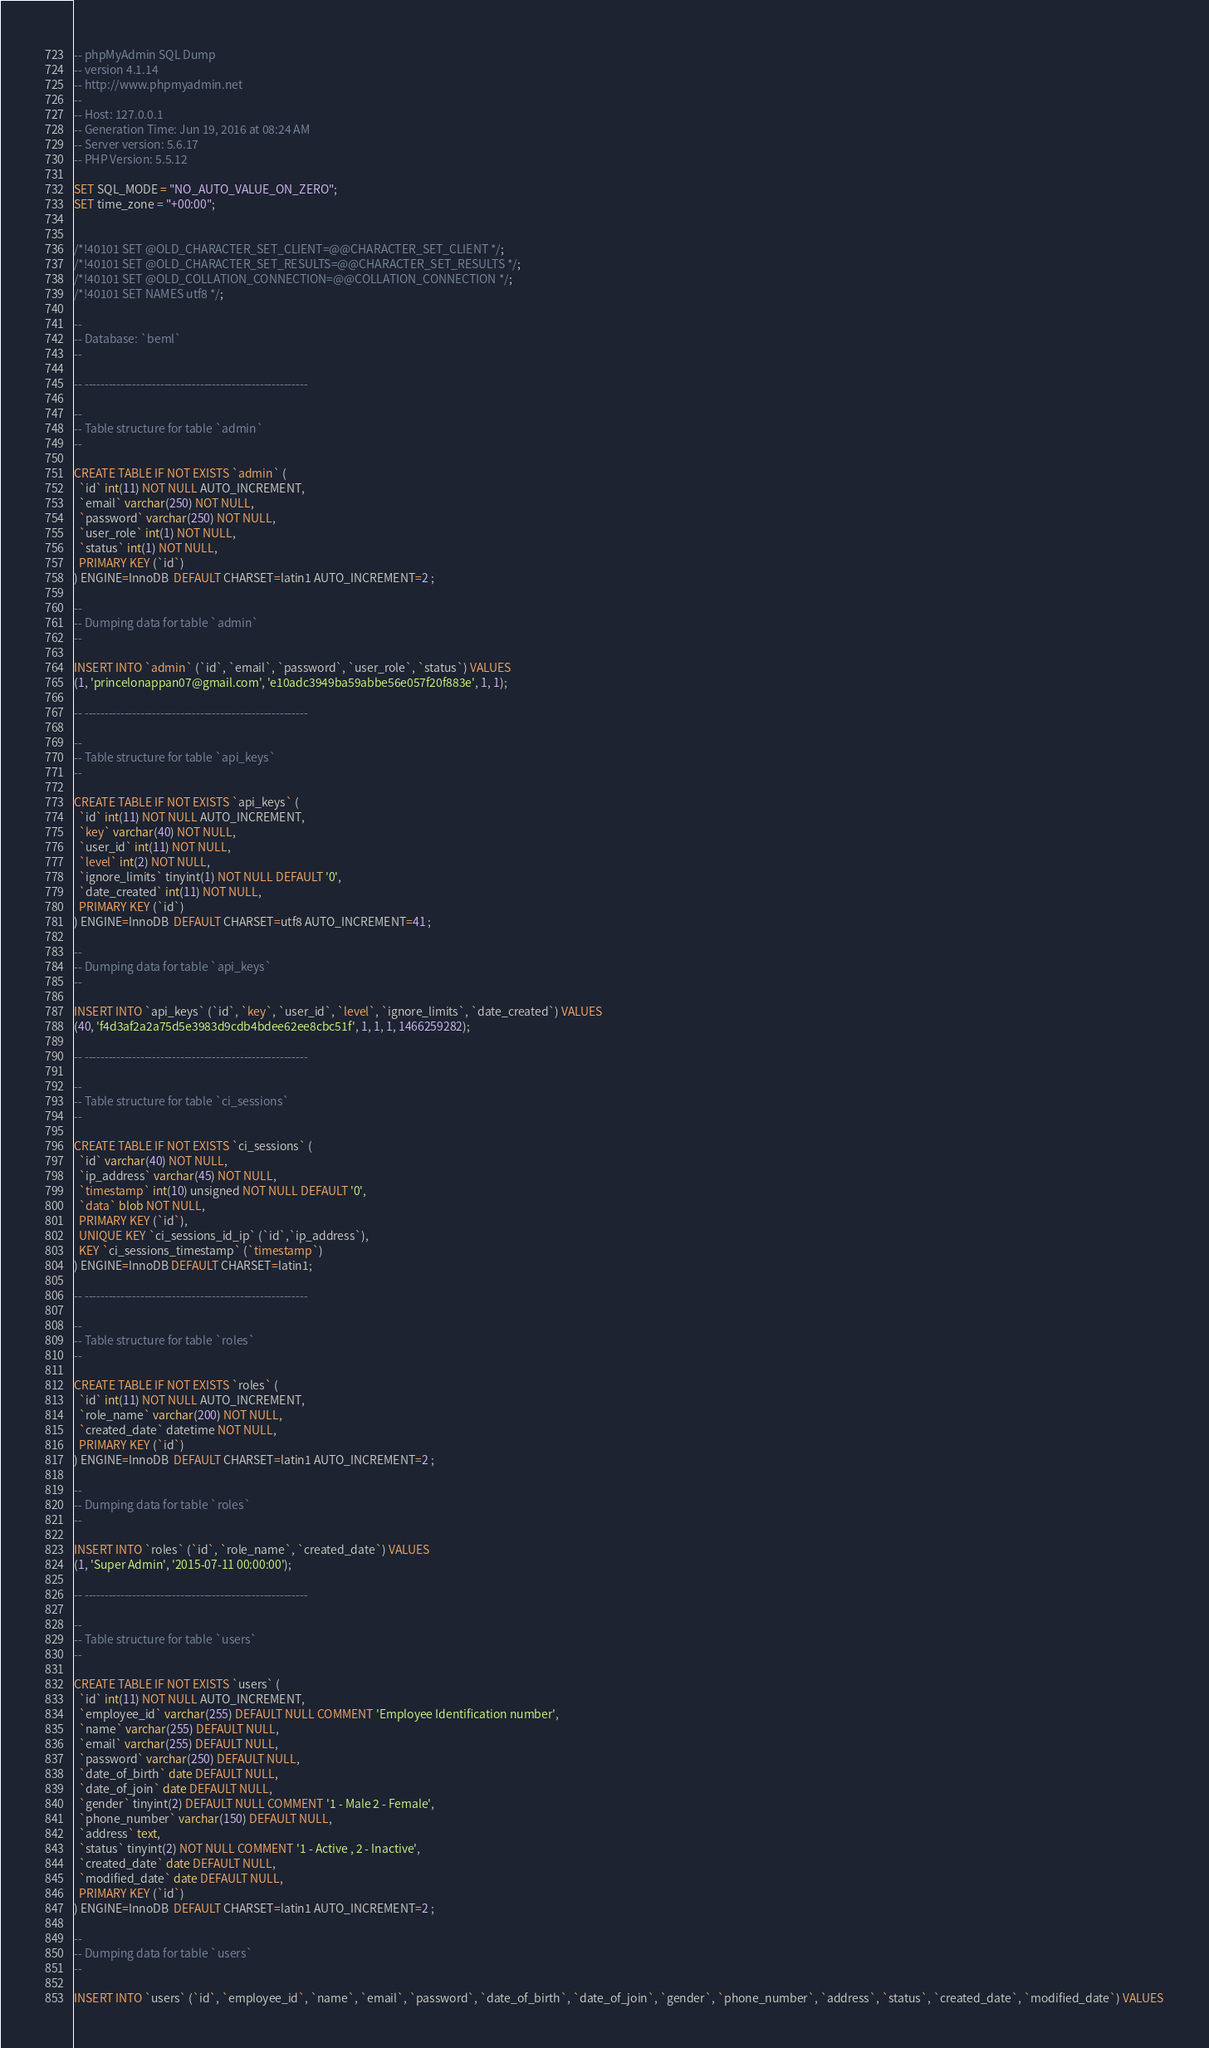Convert code to text. <code><loc_0><loc_0><loc_500><loc_500><_SQL_>-- phpMyAdmin SQL Dump
-- version 4.1.14
-- http://www.phpmyadmin.net
--
-- Host: 127.0.0.1
-- Generation Time: Jun 19, 2016 at 08:24 AM
-- Server version: 5.6.17
-- PHP Version: 5.5.12

SET SQL_MODE = "NO_AUTO_VALUE_ON_ZERO";
SET time_zone = "+00:00";


/*!40101 SET @OLD_CHARACTER_SET_CLIENT=@@CHARACTER_SET_CLIENT */;
/*!40101 SET @OLD_CHARACTER_SET_RESULTS=@@CHARACTER_SET_RESULTS */;
/*!40101 SET @OLD_COLLATION_CONNECTION=@@COLLATION_CONNECTION */;
/*!40101 SET NAMES utf8 */;

--
-- Database: `beml`
--

-- --------------------------------------------------------

--
-- Table structure for table `admin`
--

CREATE TABLE IF NOT EXISTS `admin` (
  `id` int(11) NOT NULL AUTO_INCREMENT,
  `email` varchar(250) NOT NULL,
  `password` varchar(250) NOT NULL,
  `user_role` int(1) NOT NULL,
  `status` int(1) NOT NULL,
  PRIMARY KEY (`id`)
) ENGINE=InnoDB  DEFAULT CHARSET=latin1 AUTO_INCREMENT=2 ;

--
-- Dumping data for table `admin`
--

INSERT INTO `admin` (`id`, `email`, `password`, `user_role`, `status`) VALUES
(1, 'princelonappan07@gmail.com', 'e10adc3949ba59abbe56e057f20f883e', 1, 1);

-- --------------------------------------------------------

--
-- Table structure for table `api_keys`
--

CREATE TABLE IF NOT EXISTS `api_keys` (
  `id` int(11) NOT NULL AUTO_INCREMENT,
  `key` varchar(40) NOT NULL,
  `user_id` int(11) NOT NULL,
  `level` int(2) NOT NULL,
  `ignore_limits` tinyint(1) NOT NULL DEFAULT '0',
  `date_created` int(11) NOT NULL,
  PRIMARY KEY (`id`)
) ENGINE=InnoDB  DEFAULT CHARSET=utf8 AUTO_INCREMENT=41 ;

--
-- Dumping data for table `api_keys`
--

INSERT INTO `api_keys` (`id`, `key`, `user_id`, `level`, `ignore_limits`, `date_created`) VALUES
(40, 'f4d3af2a2a75d5e3983d9cdb4bdee62ee8cbc51f', 1, 1, 1, 1466259282);

-- --------------------------------------------------------

--
-- Table structure for table `ci_sessions`
--

CREATE TABLE IF NOT EXISTS `ci_sessions` (
  `id` varchar(40) NOT NULL,
  `ip_address` varchar(45) NOT NULL,
  `timestamp` int(10) unsigned NOT NULL DEFAULT '0',
  `data` blob NOT NULL,
  PRIMARY KEY (`id`),
  UNIQUE KEY `ci_sessions_id_ip` (`id`,`ip_address`),
  KEY `ci_sessions_timestamp` (`timestamp`)
) ENGINE=InnoDB DEFAULT CHARSET=latin1;

-- --------------------------------------------------------

--
-- Table structure for table `roles`
--

CREATE TABLE IF NOT EXISTS `roles` (
  `id` int(11) NOT NULL AUTO_INCREMENT,
  `role_name` varchar(200) NOT NULL,
  `created_date` datetime NOT NULL,
  PRIMARY KEY (`id`)
) ENGINE=InnoDB  DEFAULT CHARSET=latin1 AUTO_INCREMENT=2 ;

--
-- Dumping data for table `roles`
--

INSERT INTO `roles` (`id`, `role_name`, `created_date`) VALUES
(1, 'Super Admin', '2015-07-11 00:00:00');

-- --------------------------------------------------------

--
-- Table structure for table `users`
--

CREATE TABLE IF NOT EXISTS `users` (
  `id` int(11) NOT NULL AUTO_INCREMENT,
  `employee_id` varchar(255) DEFAULT NULL COMMENT 'Employee Identification number',
  `name` varchar(255) DEFAULT NULL,
  `email` varchar(255) DEFAULT NULL,
  `password` varchar(250) DEFAULT NULL,
  `date_of_birth` date DEFAULT NULL,
  `date_of_join` date DEFAULT NULL,
  `gender` tinyint(2) DEFAULT NULL COMMENT '1 - Male 2 - Female',
  `phone_number` varchar(150) DEFAULT NULL,
  `address` text,
  `status` tinyint(2) NOT NULL COMMENT '1 - Active , 2 - Inactive',
  `created_date` date DEFAULT NULL,
  `modified_date` date DEFAULT NULL,
  PRIMARY KEY (`id`)
) ENGINE=InnoDB  DEFAULT CHARSET=latin1 AUTO_INCREMENT=2 ;

--
-- Dumping data for table `users`
--

INSERT INTO `users` (`id`, `employee_id`, `name`, `email`, `password`, `date_of_birth`, `date_of_join`, `gender`, `phone_number`, `address`, `status`, `created_date`, `modified_date`) VALUES</code> 